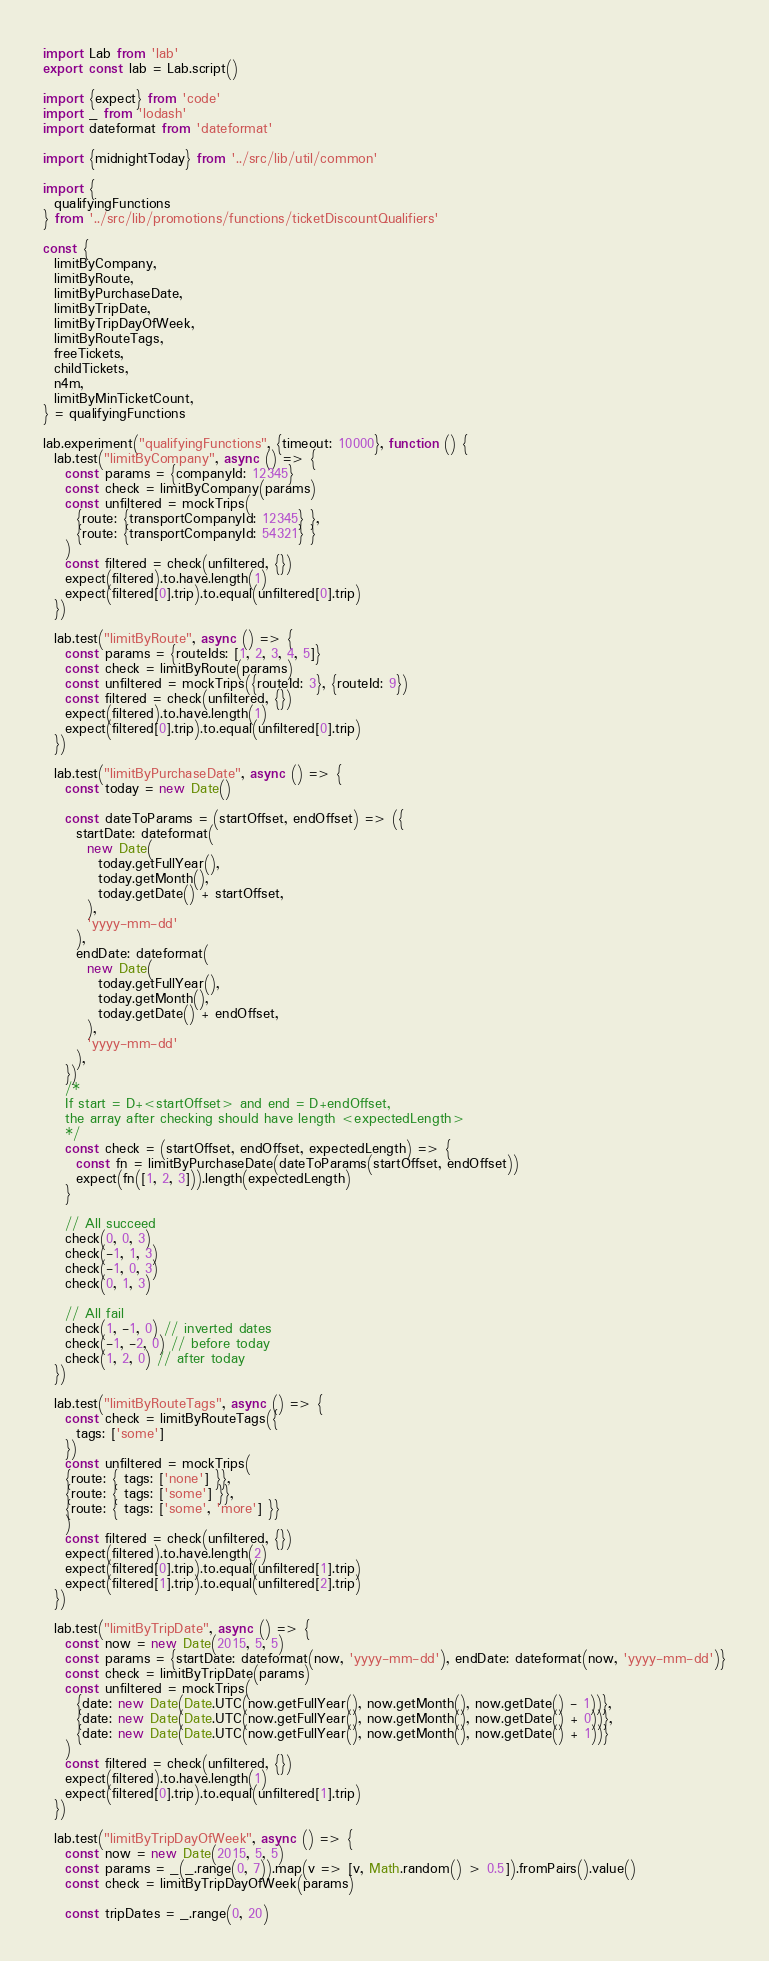Convert code to text. <code><loc_0><loc_0><loc_500><loc_500><_JavaScript_>import Lab from 'lab'
export const lab = Lab.script()

import {expect} from 'code'
import _ from 'lodash'
import dateformat from 'dateformat'

import {midnightToday} from '../src/lib/util/common'

import {
  qualifyingFunctions
} from '../src/lib/promotions/functions/ticketDiscountQualifiers'

const {
  limitByCompany,
  limitByRoute,
  limitByPurchaseDate,
  limitByTripDate,
  limitByTripDayOfWeek,
  limitByRouteTags,
  freeTickets,
  childTickets,
  n4m,
  limitByMinTicketCount,
} = qualifyingFunctions

lab.experiment("qualifyingFunctions", {timeout: 10000}, function () {
  lab.test("limitByCompany", async () => {
    const params = {companyId: 12345}
    const check = limitByCompany(params)
    const unfiltered = mockTrips(
      {route: {transportCompanyId: 12345} },
      {route: {transportCompanyId: 54321} }
    )
    const filtered = check(unfiltered, {})
    expect(filtered).to.have.length(1)
    expect(filtered[0].trip).to.equal(unfiltered[0].trip)
  })

  lab.test("limitByRoute", async () => {
    const params = {routeIds: [1, 2, 3, 4, 5]}
    const check = limitByRoute(params)
    const unfiltered = mockTrips({routeId: 3}, {routeId: 9})
    const filtered = check(unfiltered, {})
    expect(filtered).to.have.length(1)
    expect(filtered[0].trip).to.equal(unfiltered[0].trip)
  })

  lab.test("limitByPurchaseDate", async () => {
    const today = new Date()

    const dateToParams = (startOffset, endOffset) => ({
      startDate: dateformat(
        new Date(
          today.getFullYear(),
          today.getMonth(),
          today.getDate() + startOffset,
        ),
        'yyyy-mm-dd'
      ),
      endDate: dateformat(
        new Date(
          today.getFullYear(),
          today.getMonth(),
          today.getDate() + endOffset,
        ),
        'yyyy-mm-dd'
      ),
    })
    /*
    If start = D+<startOffset> and end = D+endOffset,
    the array after checking should have length <expectedLength>
    */
    const check = (startOffset, endOffset, expectedLength) => {
      const fn = limitByPurchaseDate(dateToParams(startOffset, endOffset))
      expect(fn([1, 2, 3])).length(expectedLength)
    }

    // All succeed
    check(0, 0, 3)
    check(-1, 1, 3)
    check(-1, 0, 3)
    check(0, 1, 3)

    // All fail
    check(1, -1, 0) // inverted dates
    check(-1, -2, 0) // before today
    check(1, 2, 0) // after today
  })

  lab.test("limitByRouteTags", async () => {
    const check = limitByRouteTags({
      tags: ['some']
    })
    const unfiltered = mockTrips(
    {route: { tags: ['none'] }},
    {route: { tags: ['some'] }},
    {route: { tags: ['some', 'more'] }}
    )
    const filtered = check(unfiltered, {})
    expect(filtered).to.have.length(2)
    expect(filtered[0].trip).to.equal(unfiltered[1].trip)
    expect(filtered[1].trip).to.equal(unfiltered[2].trip)
  })

  lab.test("limitByTripDate", async () => {
    const now = new Date(2015, 5, 5)
    const params = {startDate: dateformat(now, 'yyyy-mm-dd'), endDate: dateformat(now, 'yyyy-mm-dd')}
    const check = limitByTripDate(params)
    const unfiltered = mockTrips(
      {date: new Date(Date.UTC(now.getFullYear(), now.getMonth(), now.getDate() - 1))},
      {date: new Date(Date.UTC(now.getFullYear(), now.getMonth(), now.getDate() + 0))},
      {date: new Date(Date.UTC(now.getFullYear(), now.getMonth(), now.getDate() + 1))}
    )
    const filtered = check(unfiltered, {})
    expect(filtered).to.have.length(1)
    expect(filtered[0].trip).to.equal(unfiltered[1].trip)
  })

  lab.test("limitByTripDayOfWeek", async () => {
    const now = new Date(2015, 5, 5)
    const params = _(_.range(0, 7)).map(v => [v, Math.random() > 0.5]).fromPairs().value()
    const check = limitByTripDayOfWeek(params)

    const tripDates = _.range(0, 20)</code> 